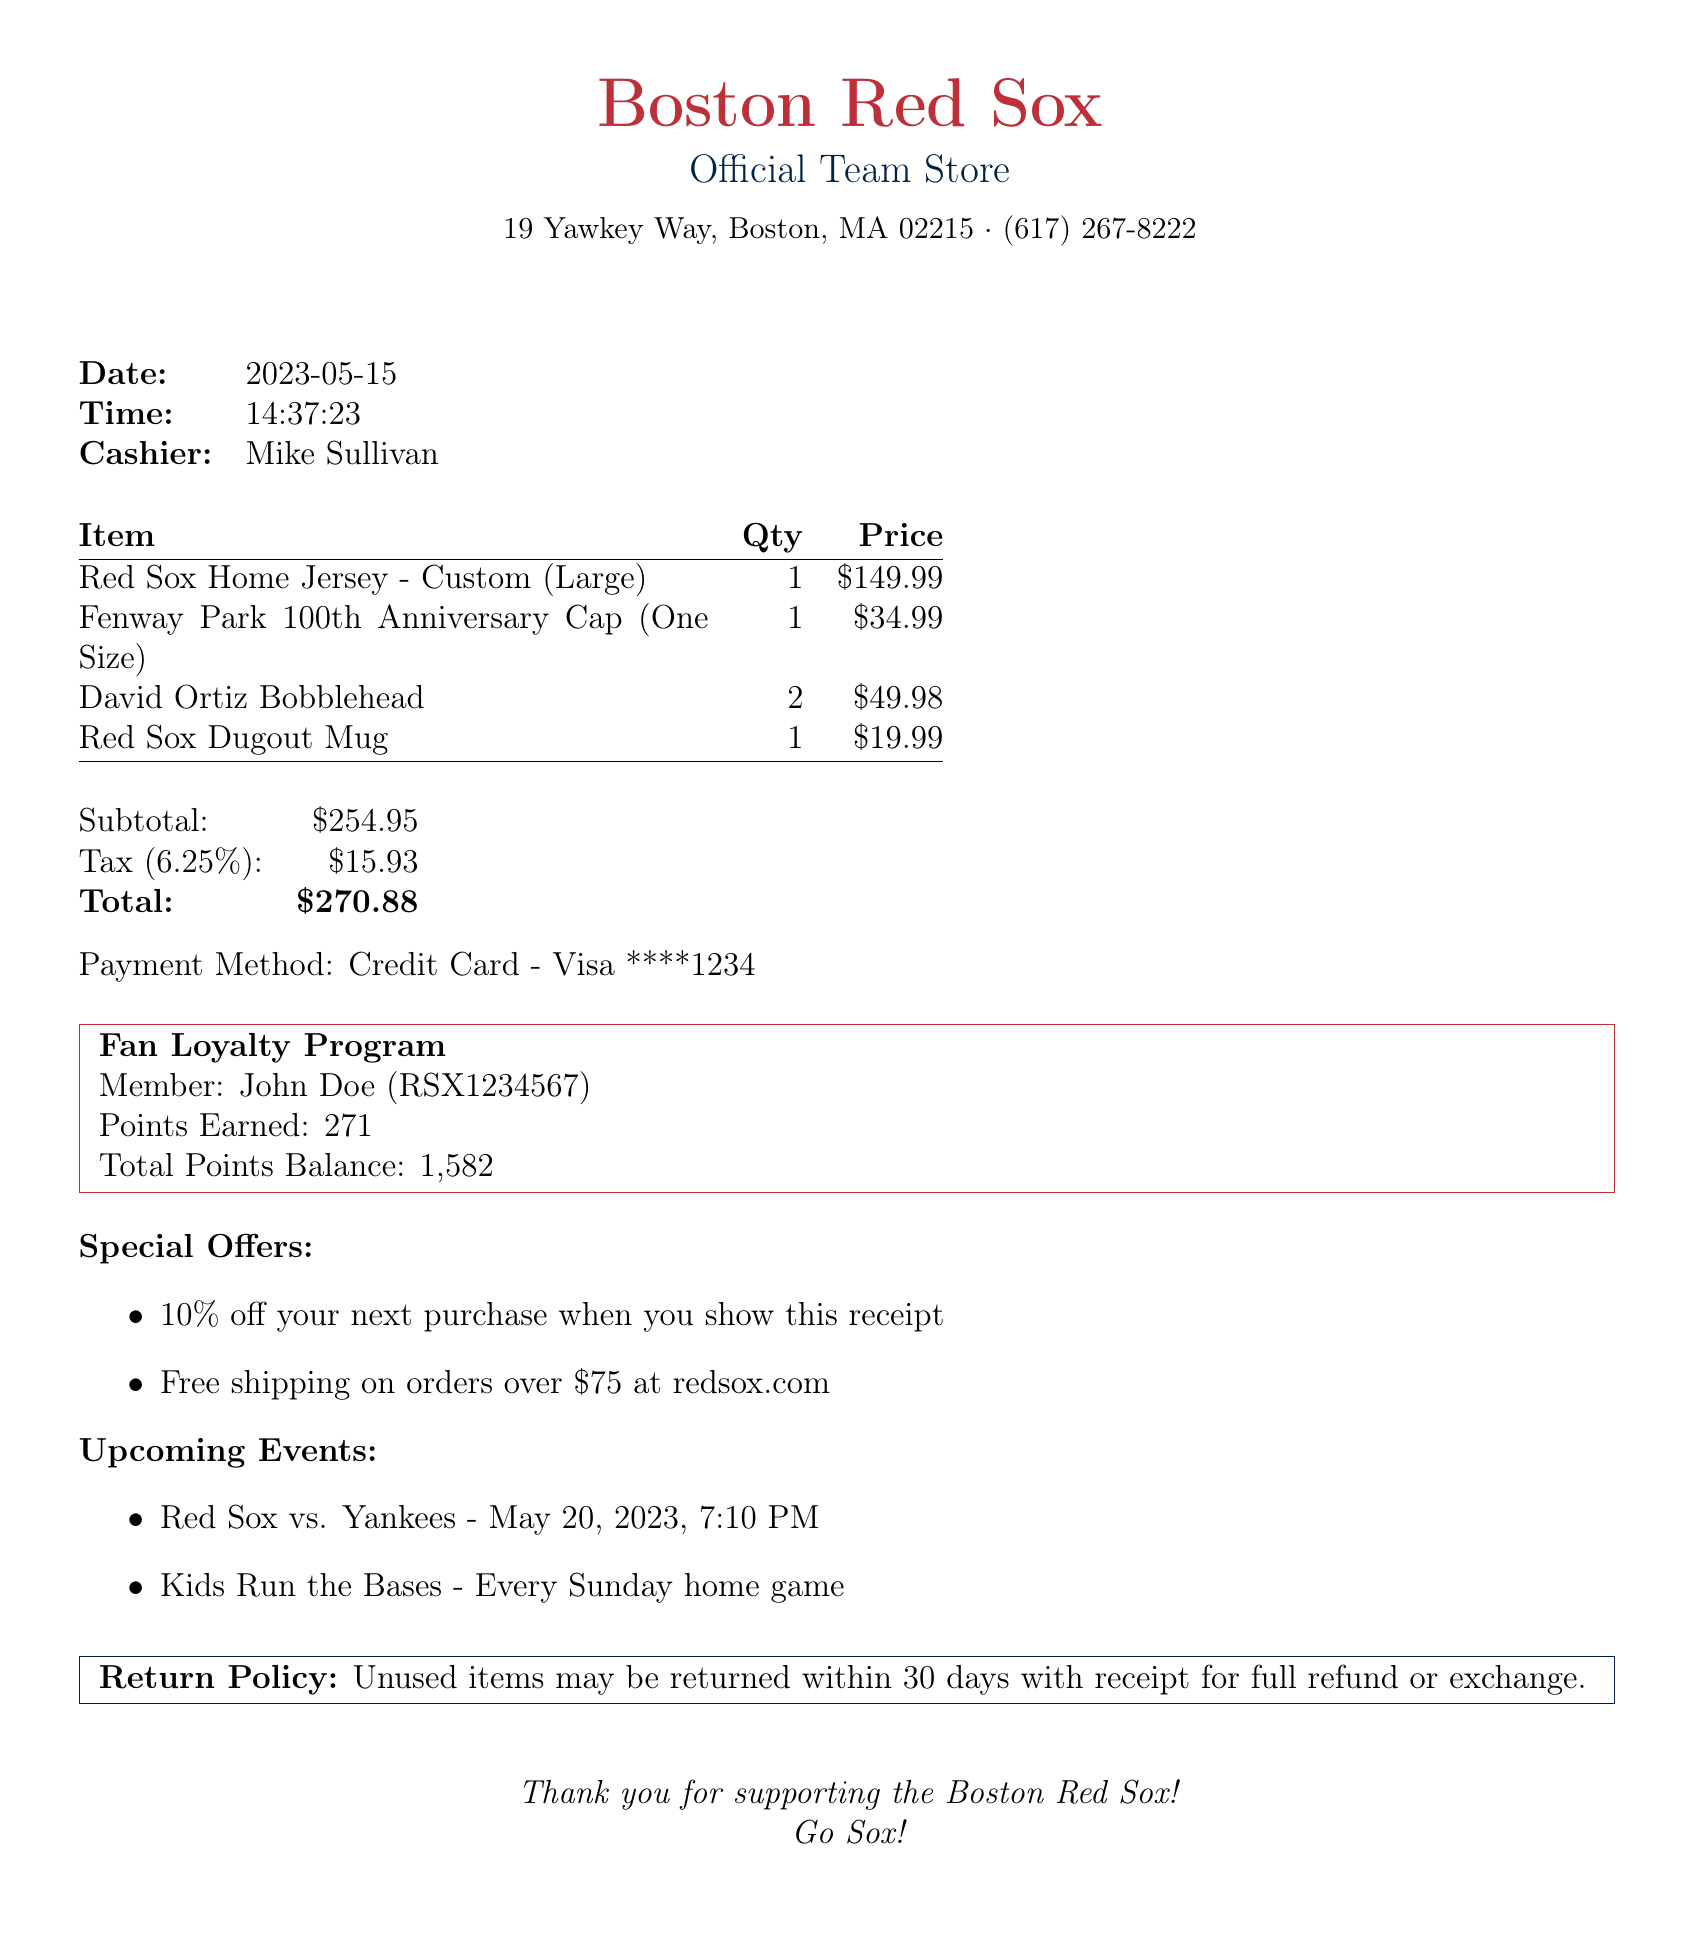What is the store name? The store name is mentioned at the top of the receipt as Boston Red Sox Official Team Store.
Answer: Boston Red Sox Official Team Store What is the transaction date? The receipt clearly states the date of the transaction.
Answer: 2023-05-15 How many David Ortiz Bobbleheads were purchased? The document lists the quantity of each item, and for David Ortiz Bobblehead, it states there were 2 purchased.
Answer: 2 What is the total amount spent? The total amount reflects the accumulation of subtotal and tax shown in the receipt.
Answer: $270.88 Who is the cashier? The cashier's name is explicitly provided on the receipt.
Answer: Mike Sullivan What are the points earned from this transaction? The points earned from the transaction are noted in the fan loyalty program section.
Answer: 271 What is the tax rate used for this purchase? The receipt states the tax rate which was applied to the subtotal.
Answer: 6.25% What special offer is available for the next purchase? The special offer is listed under the special offers section of the receipt.
Answer: 10% off your next purchase when you show this receipt What is the return policy stated in the receipt? The return policy is clearly outlined at the bottom of the receipt.
Answer: Unused items may be returned within 30 days with receipt for full refund or exchange 